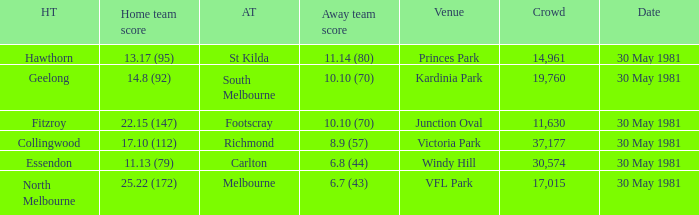What did carlton score while away? 6.8 (44). Would you be able to parse every entry in this table? {'header': ['HT', 'Home team score', 'AT', 'Away team score', 'Venue', 'Crowd', 'Date'], 'rows': [['Hawthorn', '13.17 (95)', 'St Kilda', '11.14 (80)', 'Princes Park', '14,961', '30 May 1981'], ['Geelong', '14.8 (92)', 'South Melbourne', '10.10 (70)', 'Kardinia Park', '19,760', '30 May 1981'], ['Fitzroy', '22.15 (147)', 'Footscray', '10.10 (70)', 'Junction Oval', '11,630', '30 May 1981'], ['Collingwood', '17.10 (112)', 'Richmond', '8.9 (57)', 'Victoria Park', '37,177', '30 May 1981'], ['Essendon', '11.13 (79)', 'Carlton', '6.8 (44)', 'Windy Hill', '30,574', '30 May 1981'], ['North Melbourne', '25.22 (172)', 'Melbourne', '6.7 (43)', 'VFL Park', '17,015', '30 May 1981']]} 